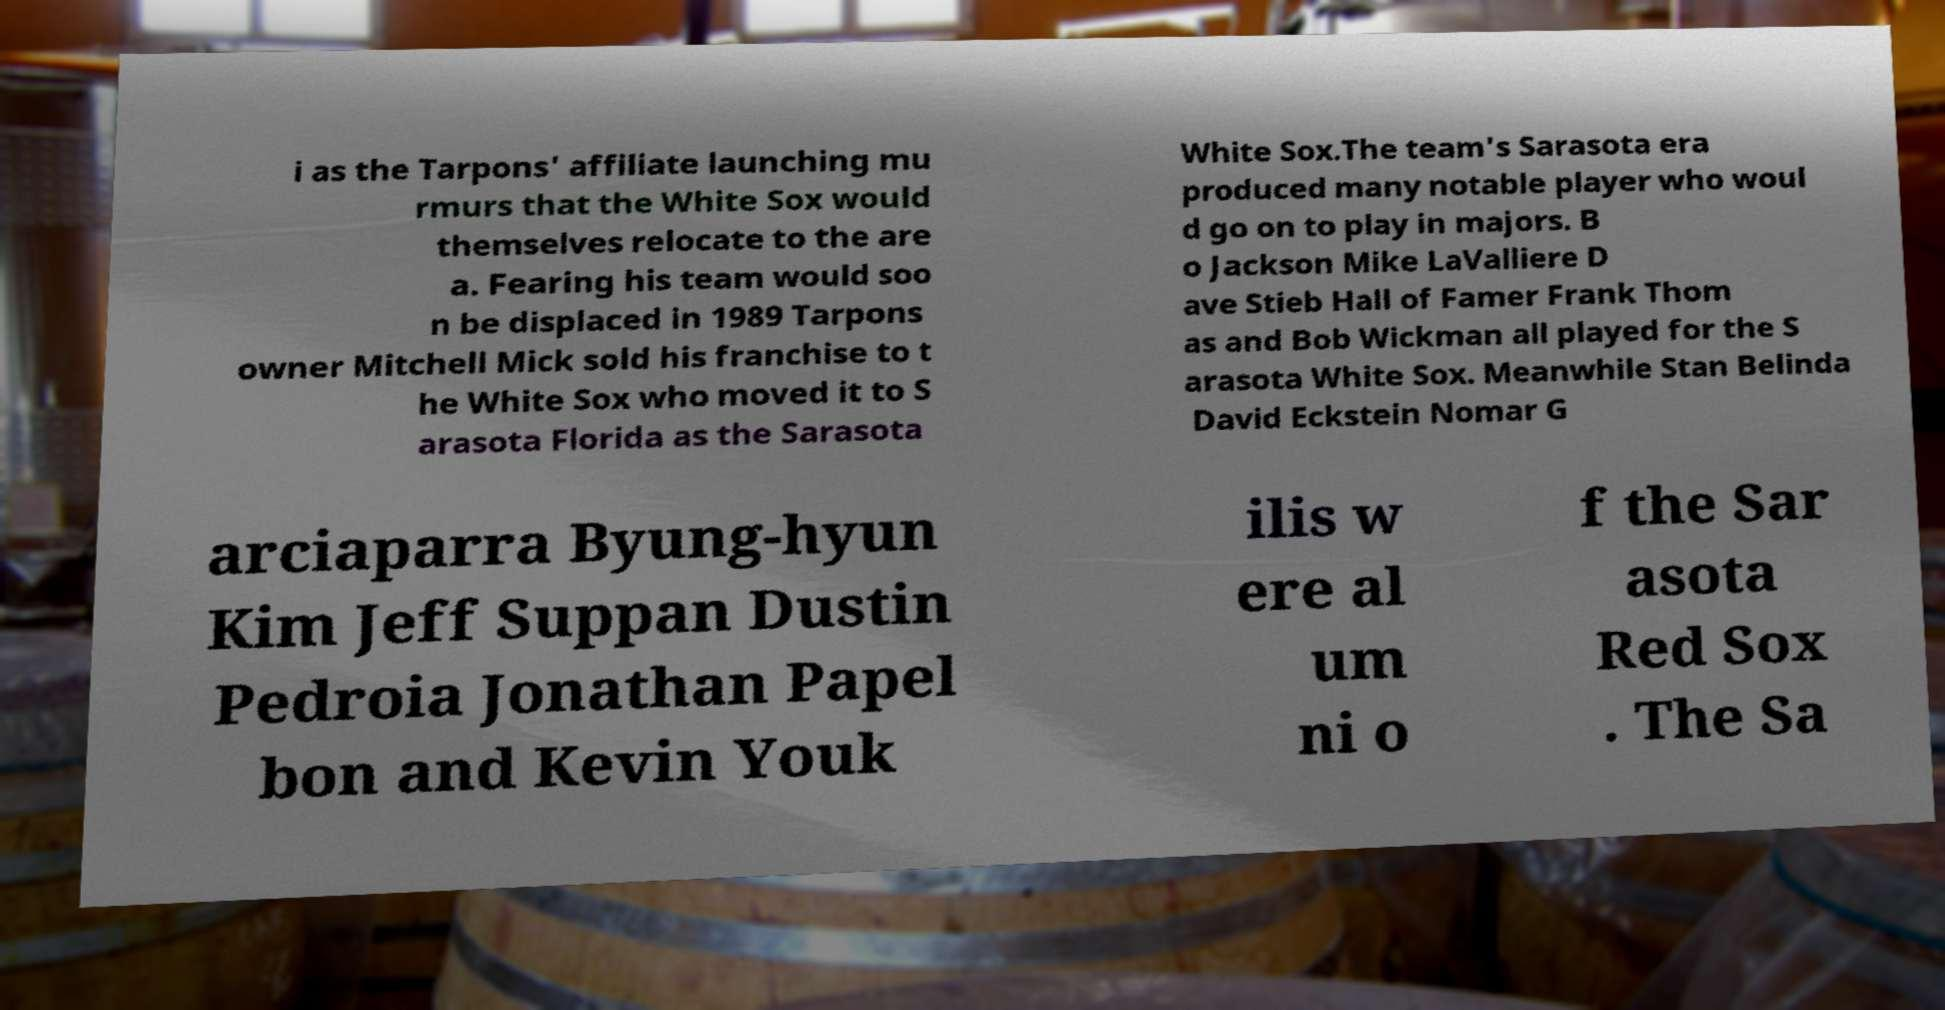Could you extract and type out the text from this image? i as the Tarpons' affiliate launching mu rmurs that the White Sox would themselves relocate to the are a. Fearing his team would soo n be displaced in 1989 Tarpons owner Mitchell Mick sold his franchise to t he White Sox who moved it to S arasota Florida as the Sarasota White Sox.The team's Sarasota era produced many notable player who woul d go on to play in majors. B o Jackson Mike LaValliere D ave Stieb Hall of Famer Frank Thom as and Bob Wickman all played for the S arasota White Sox. Meanwhile Stan Belinda David Eckstein Nomar G arciaparra Byung-hyun Kim Jeff Suppan Dustin Pedroia Jonathan Papel bon and Kevin Youk ilis w ere al um ni o f the Sar asota Red Sox . The Sa 